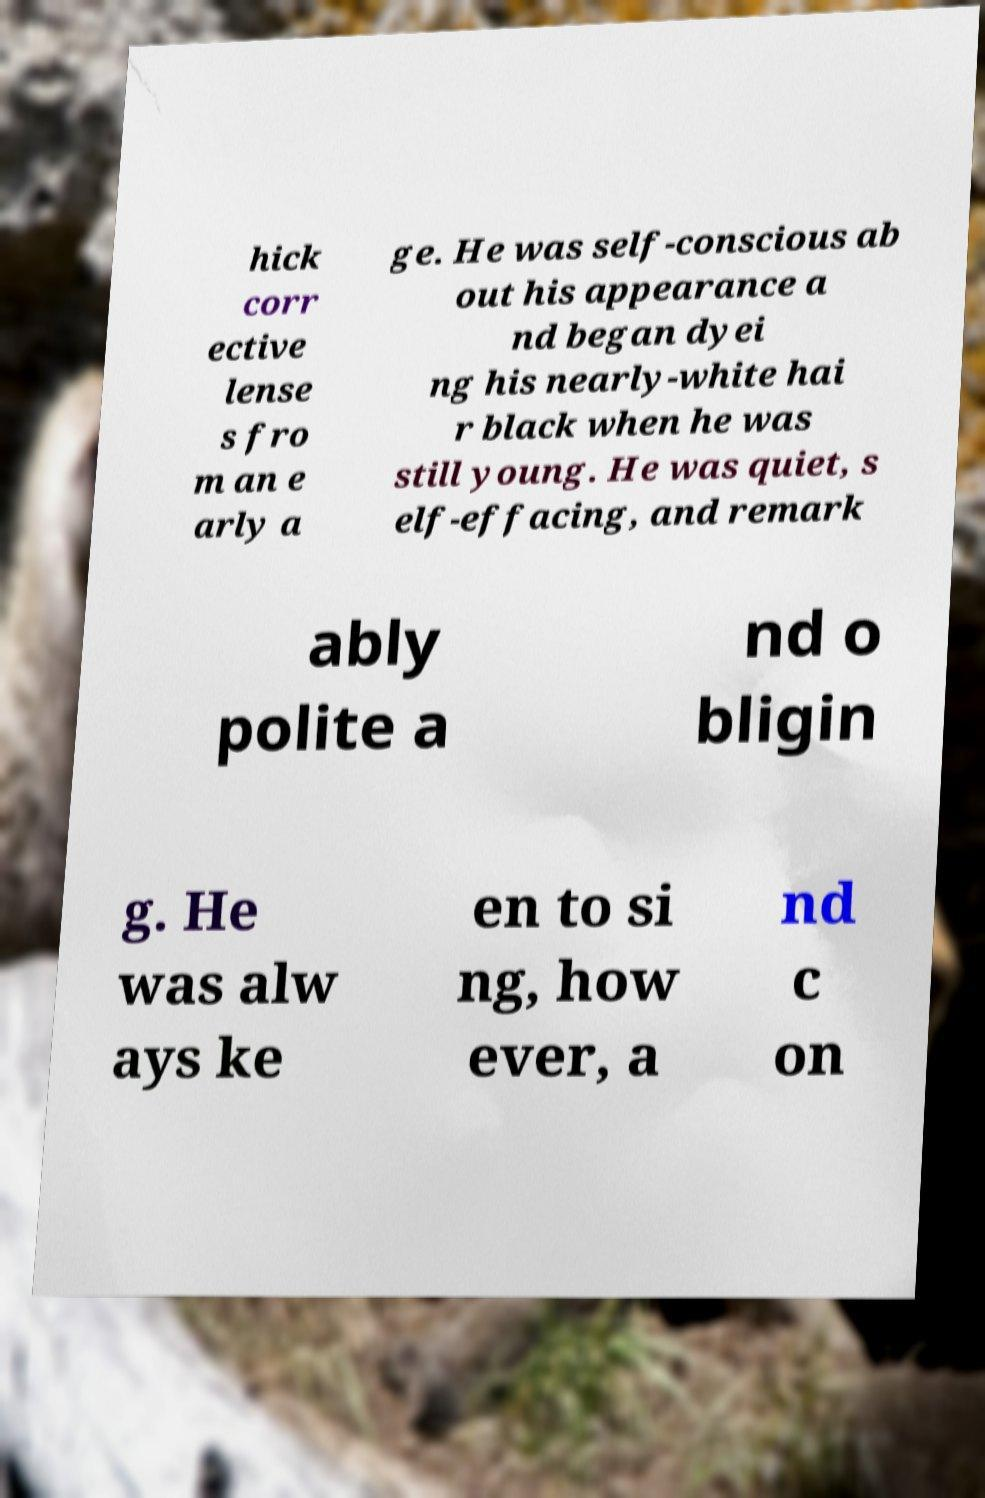For documentation purposes, I need the text within this image transcribed. Could you provide that? hick corr ective lense s fro m an e arly a ge. He was self-conscious ab out his appearance a nd began dyei ng his nearly-white hai r black when he was still young. He was quiet, s elf-effacing, and remark ably polite a nd o bligin g. He was alw ays ke en to si ng, how ever, a nd c on 